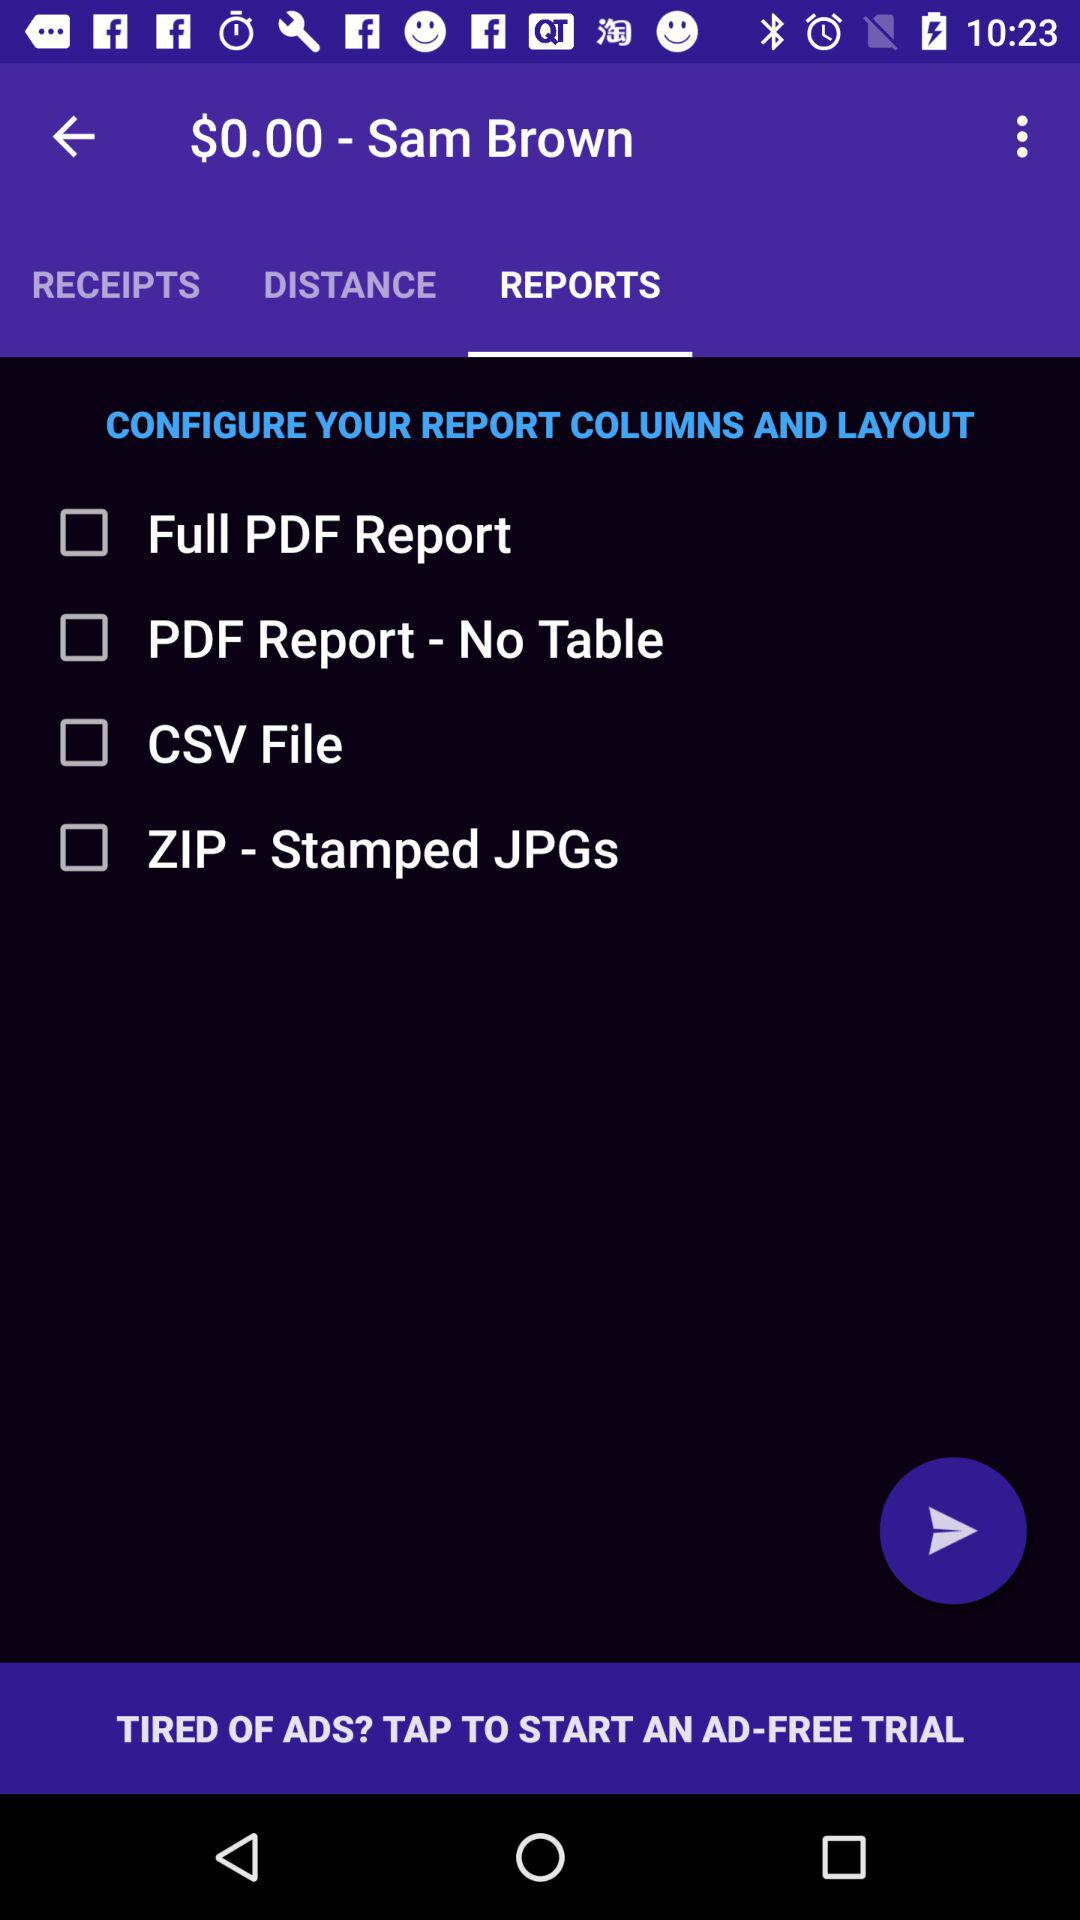What is the remaining balance of Sam Brown? The remaining balance of Sam Brown is $0.00. 